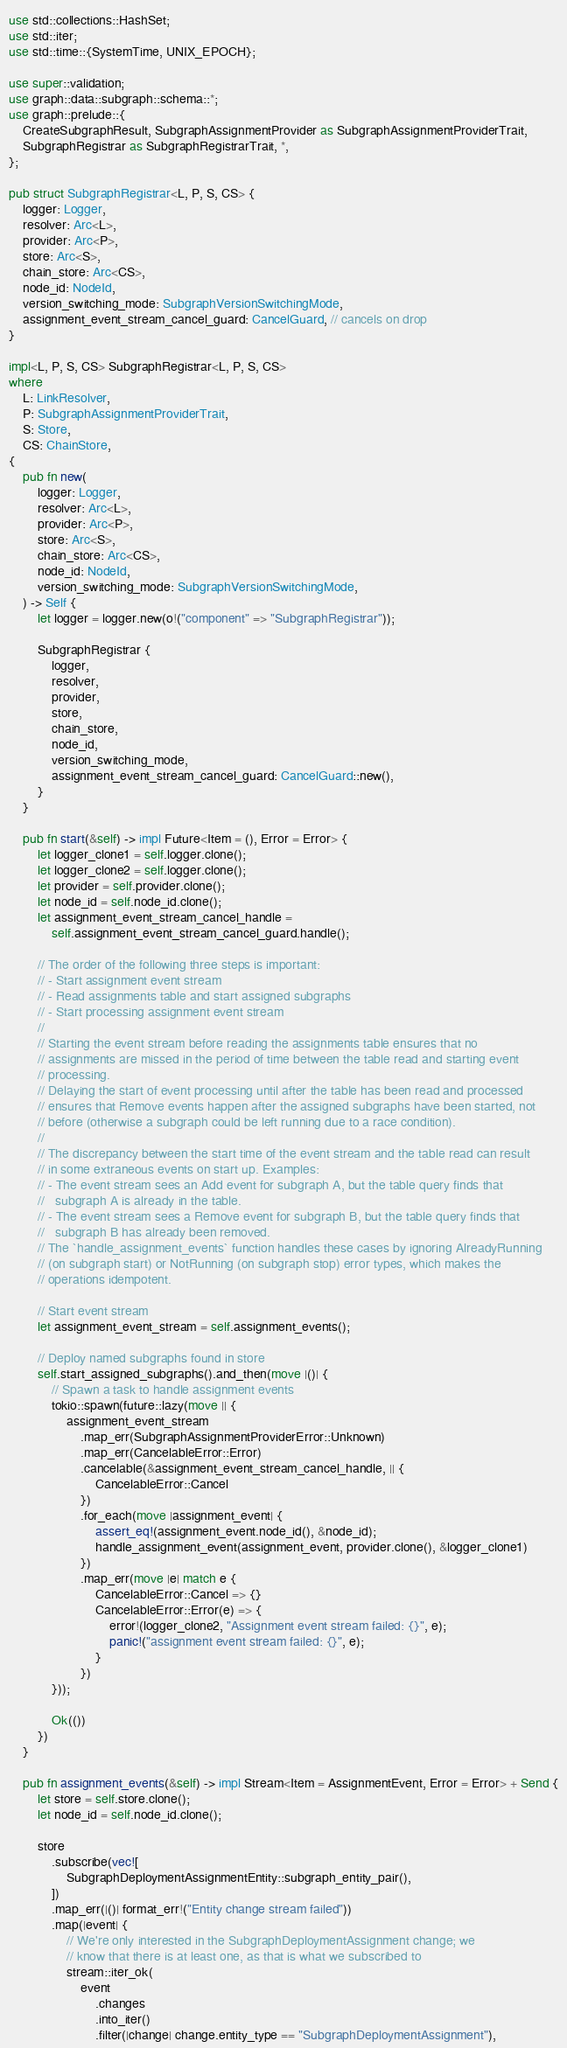Convert code to text. <code><loc_0><loc_0><loc_500><loc_500><_Rust_>use std::collections::HashSet;
use std::iter;
use std::time::{SystemTime, UNIX_EPOCH};

use super::validation;
use graph::data::subgraph::schema::*;
use graph::prelude::{
    CreateSubgraphResult, SubgraphAssignmentProvider as SubgraphAssignmentProviderTrait,
    SubgraphRegistrar as SubgraphRegistrarTrait, *,
};

pub struct SubgraphRegistrar<L, P, S, CS> {
    logger: Logger,
    resolver: Arc<L>,
    provider: Arc<P>,
    store: Arc<S>,
    chain_store: Arc<CS>,
    node_id: NodeId,
    version_switching_mode: SubgraphVersionSwitchingMode,
    assignment_event_stream_cancel_guard: CancelGuard, // cancels on drop
}

impl<L, P, S, CS> SubgraphRegistrar<L, P, S, CS>
where
    L: LinkResolver,
    P: SubgraphAssignmentProviderTrait,
    S: Store,
    CS: ChainStore,
{
    pub fn new(
        logger: Logger,
        resolver: Arc<L>,
        provider: Arc<P>,
        store: Arc<S>,
        chain_store: Arc<CS>,
        node_id: NodeId,
        version_switching_mode: SubgraphVersionSwitchingMode,
    ) -> Self {
        let logger = logger.new(o!("component" => "SubgraphRegistrar"));

        SubgraphRegistrar {
            logger,
            resolver,
            provider,
            store,
            chain_store,
            node_id,
            version_switching_mode,
            assignment_event_stream_cancel_guard: CancelGuard::new(),
        }
    }

    pub fn start(&self) -> impl Future<Item = (), Error = Error> {
        let logger_clone1 = self.logger.clone();
        let logger_clone2 = self.logger.clone();
        let provider = self.provider.clone();
        let node_id = self.node_id.clone();
        let assignment_event_stream_cancel_handle =
            self.assignment_event_stream_cancel_guard.handle();

        // The order of the following three steps is important:
        // - Start assignment event stream
        // - Read assignments table and start assigned subgraphs
        // - Start processing assignment event stream
        //
        // Starting the event stream before reading the assignments table ensures that no
        // assignments are missed in the period of time between the table read and starting event
        // processing.
        // Delaying the start of event processing until after the table has been read and processed
        // ensures that Remove events happen after the assigned subgraphs have been started, not
        // before (otherwise a subgraph could be left running due to a race condition).
        //
        // The discrepancy between the start time of the event stream and the table read can result
        // in some extraneous events on start up. Examples:
        // - The event stream sees an Add event for subgraph A, but the table query finds that
        //   subgraph A is already in the table.
        // - The event stream sees a Remove event for subgraph B, but the table query finds that
        //   subgraph B has already been removed.
        // The `handle_assignment_events` function handles these cases by ignoring AlreadyRunning
        // (on subgraph start) or NotRunning (on subgraph stop) error types, which makes the
        // operations idempotent.

        // Start event stream
        let assignment_event_stream = self.assignment_events();

        // Deploy named subgraphs found in store
        self.start_assigned_subgraphs().and_then(move |()| {
            // Spawn a task to handle assignment events
            tokio::spawn(future::lazy(move || {
                assignment_event_stream
                    .map_err(SubgraphAssignmentProviderError::Unknown)
                    .map_err(CancelableError::Error)
                    .cancelable(&assignment_event_stream_cancel_handle, || {
                        CancelableError::Cancel
                    })
                    .for_each(move |assignment_event| {
                        assert_eq!(assignment_event.node_id(), &node_id);
                        handle_assignment_event(assignment_event, provider.clone(), &logger_clone1)
                    })
                    .map_err(move |e| match e {
                        CancelableError::Cancel => {}
                        CancelableError::Error(e) => {
                            error!(logger_clone2, "Assignment event stream failed: {}", e);
                            panic!("assignment event stream failed: {}", e);
                        }
                    })
            }));

            Ok(())
        })
    }

    pub fn assignment_events(&self) -> impl Stream<Item = AssignmentEvent, Error = Error> + Send {
        let store = self.store.clone();
        let node_id = self.node_id.clone();

        store
            .subscribe(vec![
                SubgraphDeploymentAssignmentEntity::subgraph_entity_pair(),
            ])
            .map_err(|()| format_err!("Entity change stream failed"))
            .map(|event| {
                // We're only interested in the SubgraphDeploymentAssignment change; we
                // know that there is at least one, as that is what we subscribed to
                stream::iter_ok(
                    event
                        .changes
                        .into_iter()
                        .filter(|change| change.entity_type == "SubgraphDeploymentAssignment"),</code> 